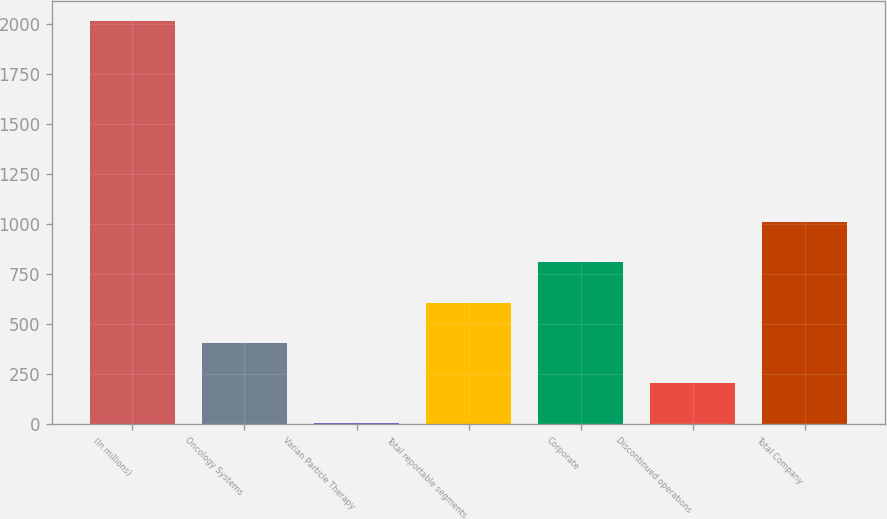Convert chart to OTSL. <chart><loc_0><loc_0><loc_500><loc_500><bar_chart><fcel>(In millions)<fcel>Oncology Systems<fcel>Varian Particle Therapy<fcel>Total reportable segments<fcel>Corporate<fcel>Discontinued operations<fcel>Total Company<nl><fcel>2015<fcel>406.84<fcel>4.8<fcel>607.86<fcel>808.88<fcel>205.82<fcel>1009.9<nl></chart> 